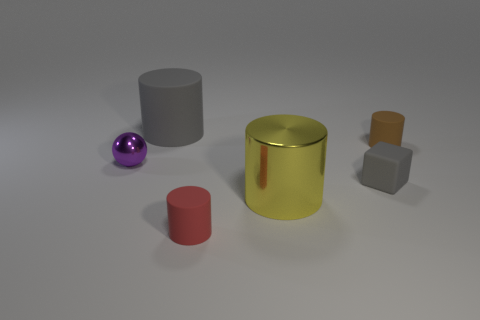What is the shape of the large object that is behind the small sphere in front of the big gray rubber cylinder? The large object behind the small sphere and in front of the big gray cylinder is a metallic gold cylinder. 